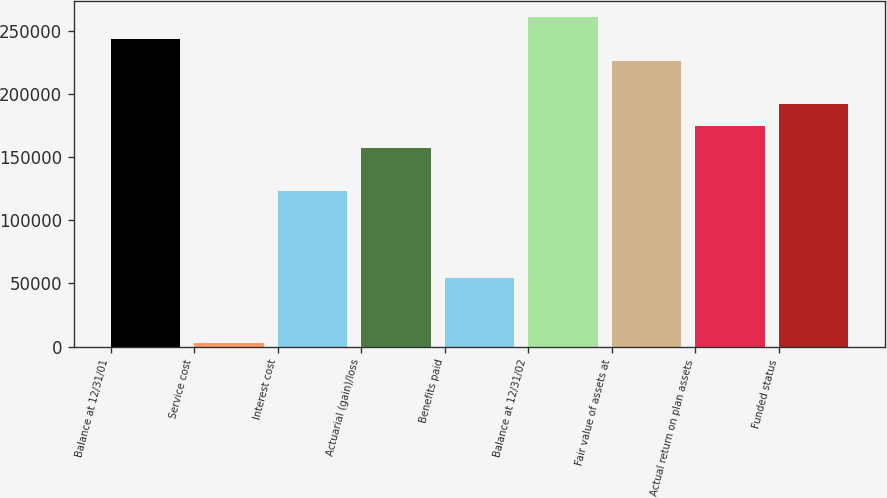Convert chart. <chart><loc_0><loc_0><loc_500><loc_500><bar_chart><fcel>Balance at 12/31/01<fcel>Service cost<fcel>Interest cost<fcel>Actuarial (gain)/loss<fcel>Benefits paid<fcel>Balance at 12/31/02<fcel>Fair value of assets at<fcel>Actual return on plan assets<fcel>Funded status<nl><fcel>243274<fcel>2971<fcel>123122<fcel>157452<fcel>54464.5<fcel>260438<fcel>226110<fcel>174616<fcel>191780<nl></chart> 